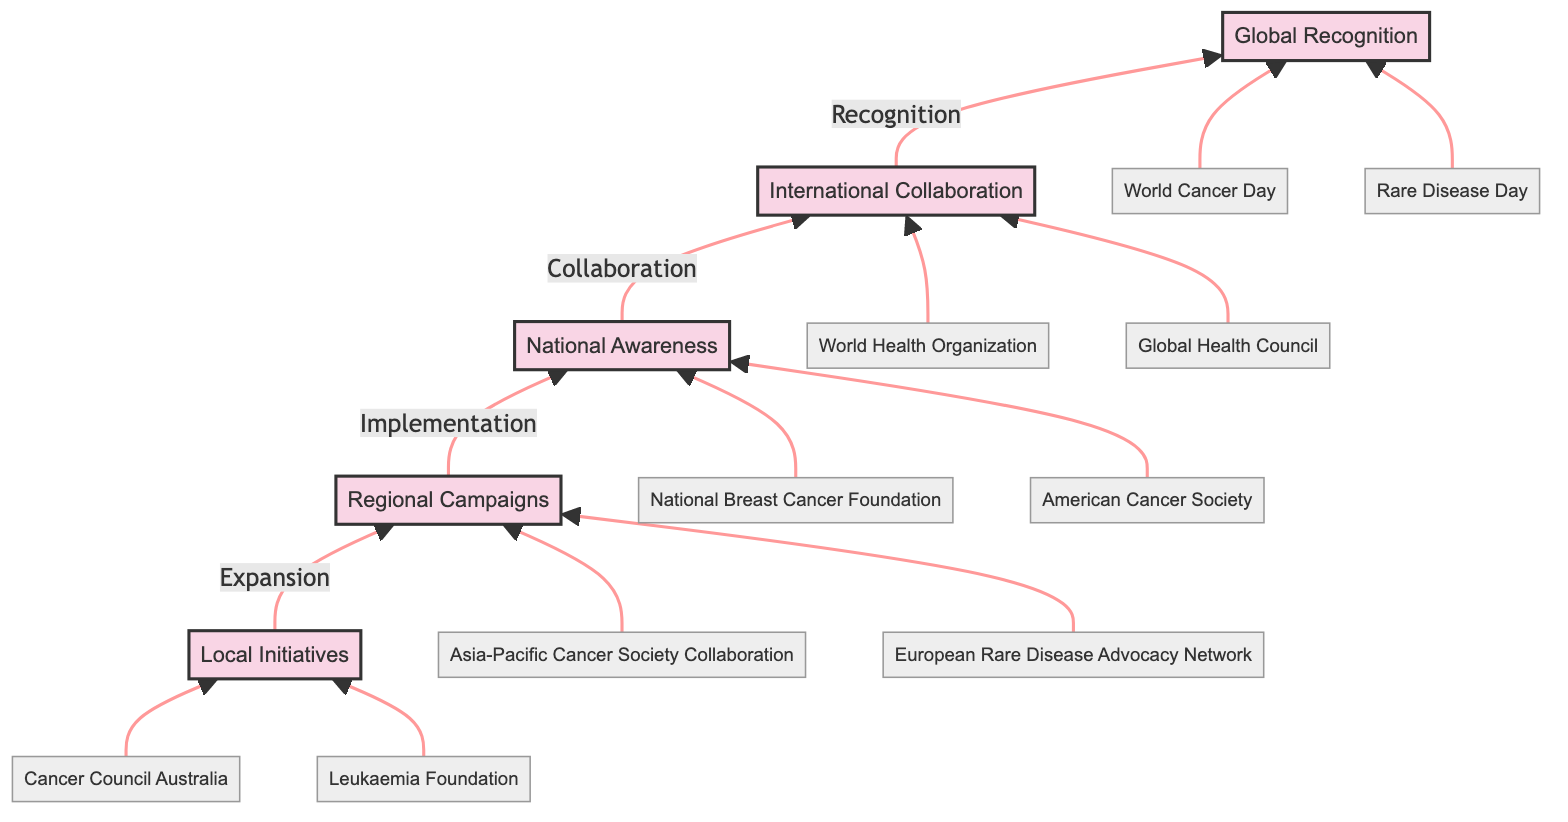What is the top stage in the diagram? The top stage in the diagram is the last node, which is labeled "Global Recognition." It is located at the uppermost part of the flow chart.
Answer: Global Recognition How many stages are shown in the diagram? By counting the distinct stages presented in the diagram, we find five stages: Local Initiatives, Regional Campaigns, National Awareness, International Collaboration, and Global Recognition.
Answer: Five Which stage immediately precedes National Awareness? The stage that directly leads to National Awareness in the flow chart is Regional Campaigns, which connects to it via an arrow.
Answer: Regional Campaigns What collaborations are included in the International Collaboration stage? The examples given under the International Collaboration stage include "World Health Organization" and "Global Health Council," which are listed beneath this stage.
Answer: World Health Organization, Global Health Council Which example is associated with Local Initiatives? The examples mentioned under Local Initiatives are "Cancer Council Australia" and "Leukaemia Foundation," thus either of these can be considered an answer.
Answer: Cancer Council Australia What is the significance of Global Recognition? Global Recognition is characterized by worldwide acknowledgment and observance of campaigns, illustrated by examples like "World Cancer Day" and "Rare Disease Day" that emphasize its importance on an international scale.
Answer: Worldwide recognition and commemoration How does the flow chart represent the evolution of awareness campaigns? The diagram visually organizes the stages from grassroots movements at the bottom to their global recognition at the top, illustrating the progression and expansion of awareness efforts over time.
Answer: Bottom to top evolution Which stage has examples associated with both public and private sectors? The National Awareness stage features examples like the National Breast Cancer Foundation and the American Cancer Society, indicating support from both government and corporate sponsorship.
Answer: National Awareness What type of initiatives does the Local Initiatives stage primarily consist of? Local Initiatives are primarily made up of community-driven projects and local nonprofits focused on raising awareness, as described in the diagram.
Answer: Community-driven projects 